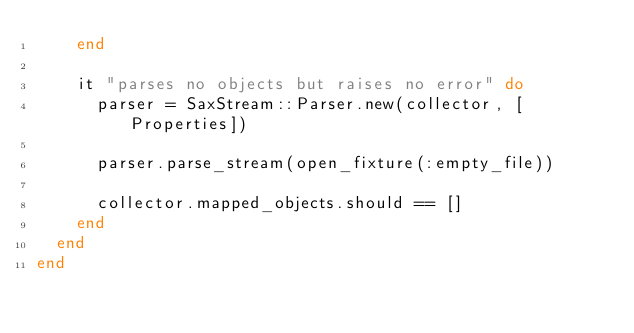<code> <loc_0><loc_0><loc_500><loc_500><_Ruby_>    end

    it "parses no objects but raises no error" do
      parser = SaxStream::Parser.new(collector, [Properties])

      parser.parse_stream(open_fixture(:empty_file))

      collector.mapped_objects.should == []
    end
  end
end</code> 